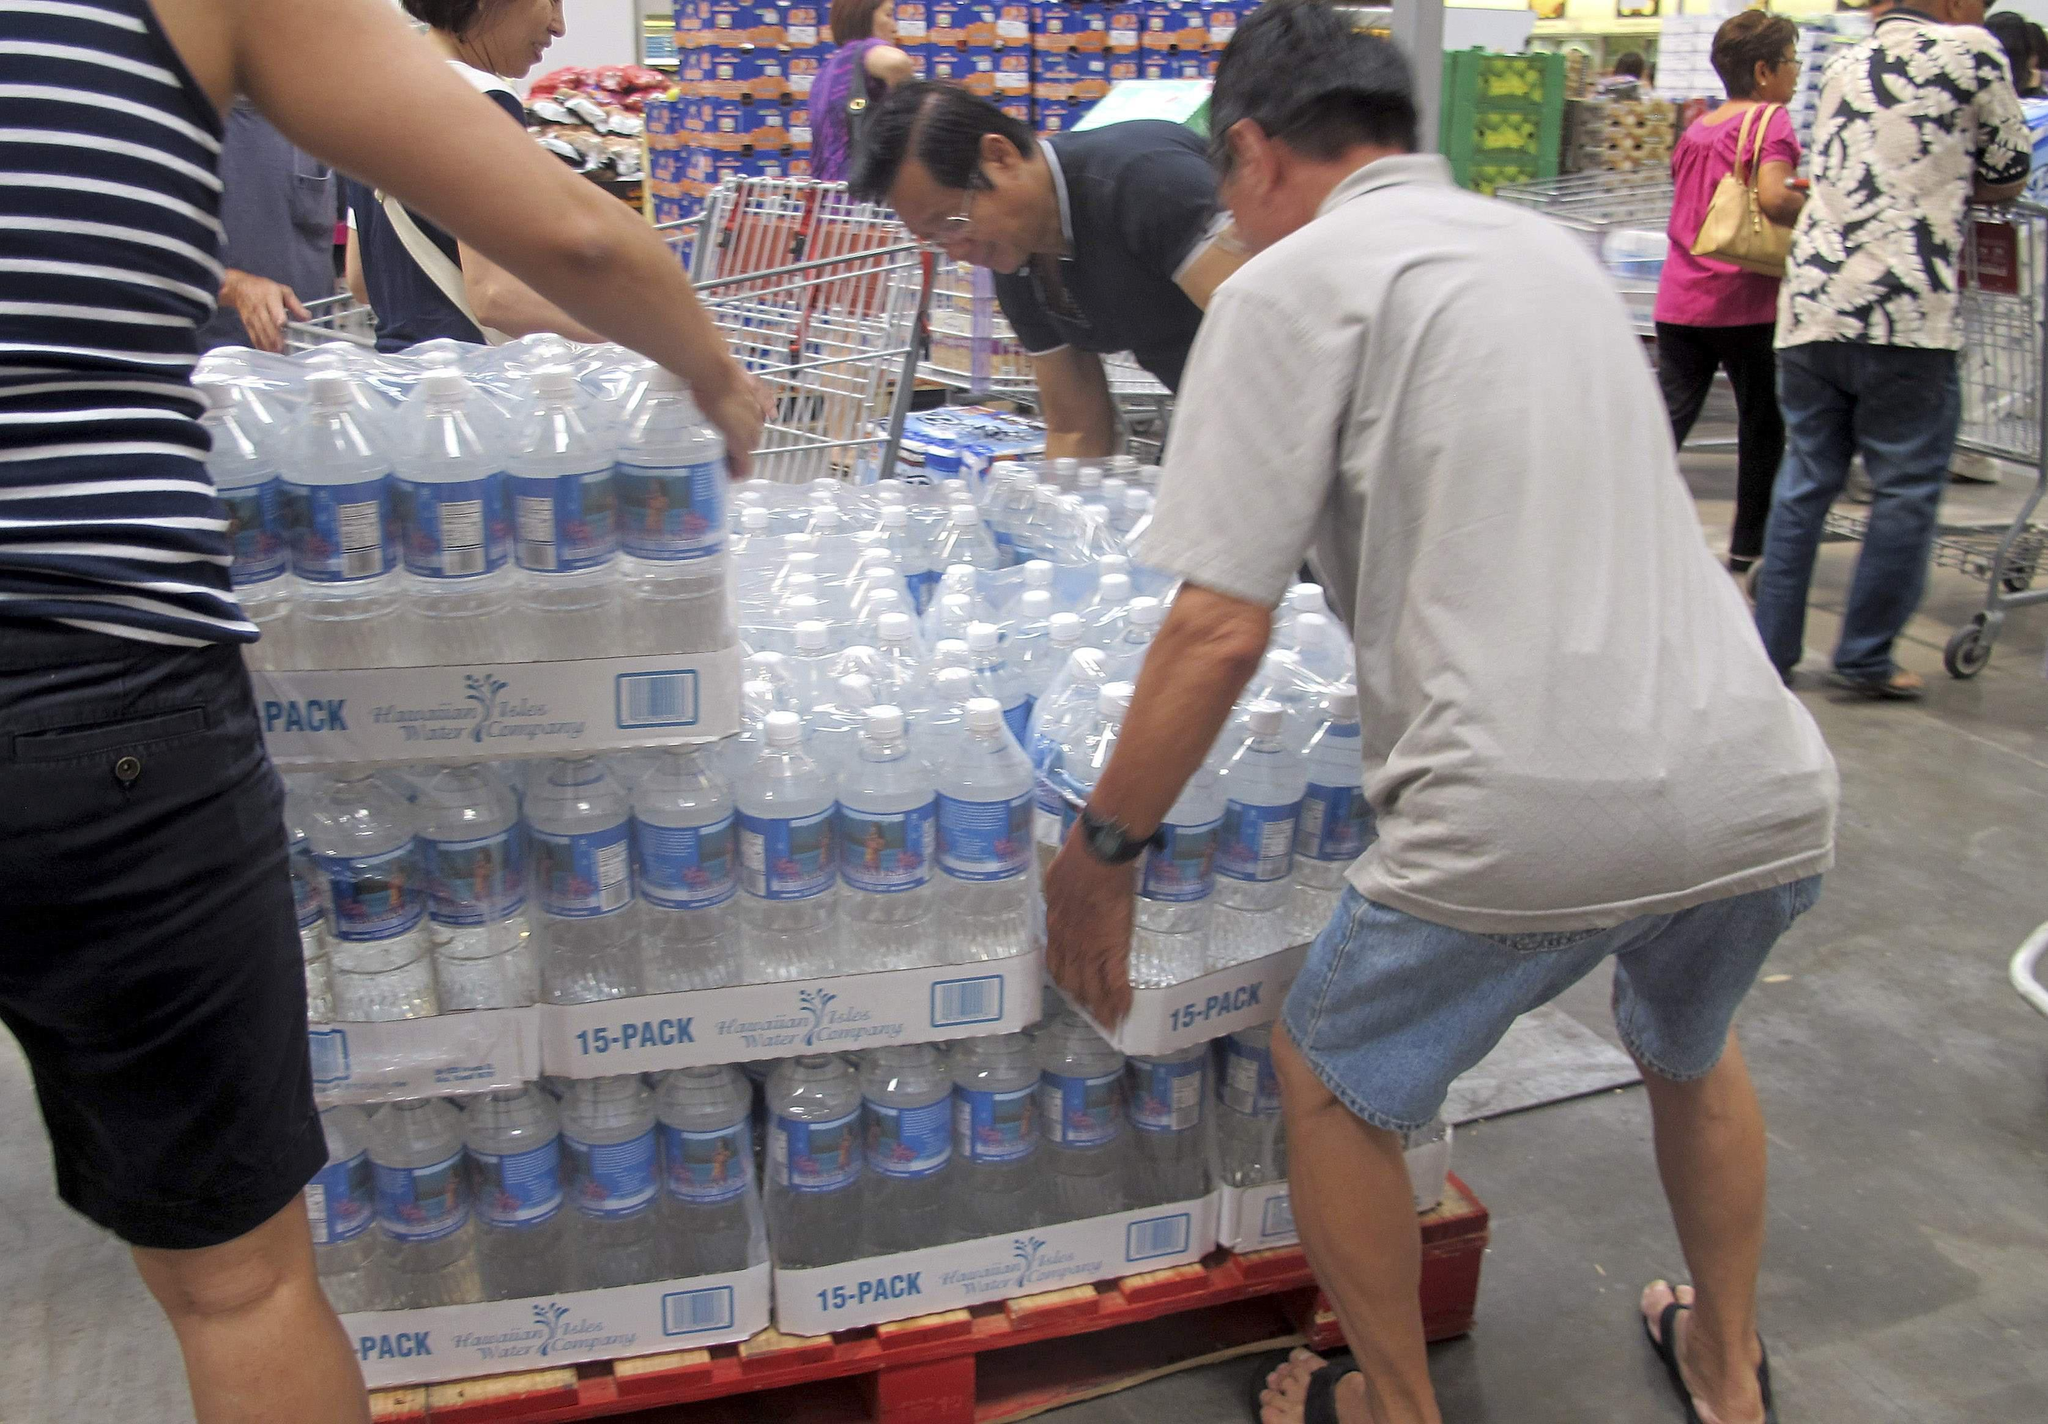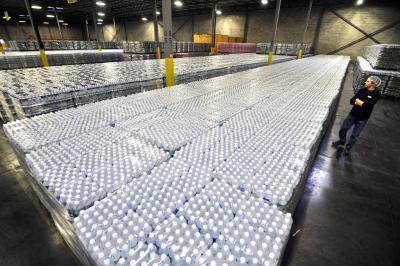The first image is the image on the left, the second image is the image on the right. For the images shown, is this caption "There are at least two people in the image on the right." true? Answer yes or no. No. 